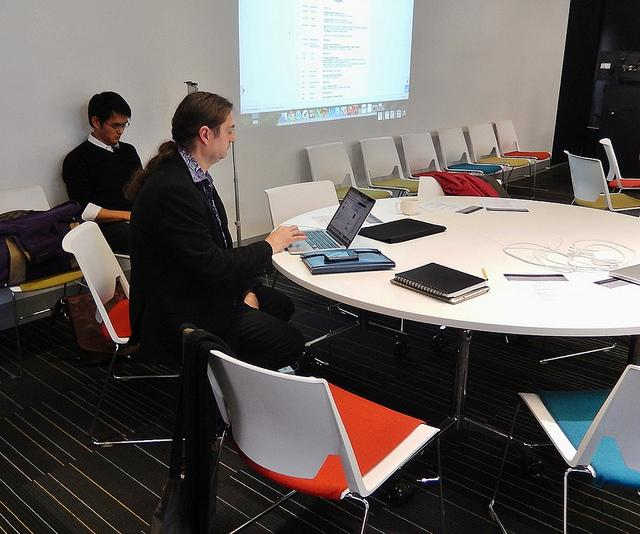What is the operating system being projected? Please explain your reasoning. mac os. The operating system being shown is an apple system. 